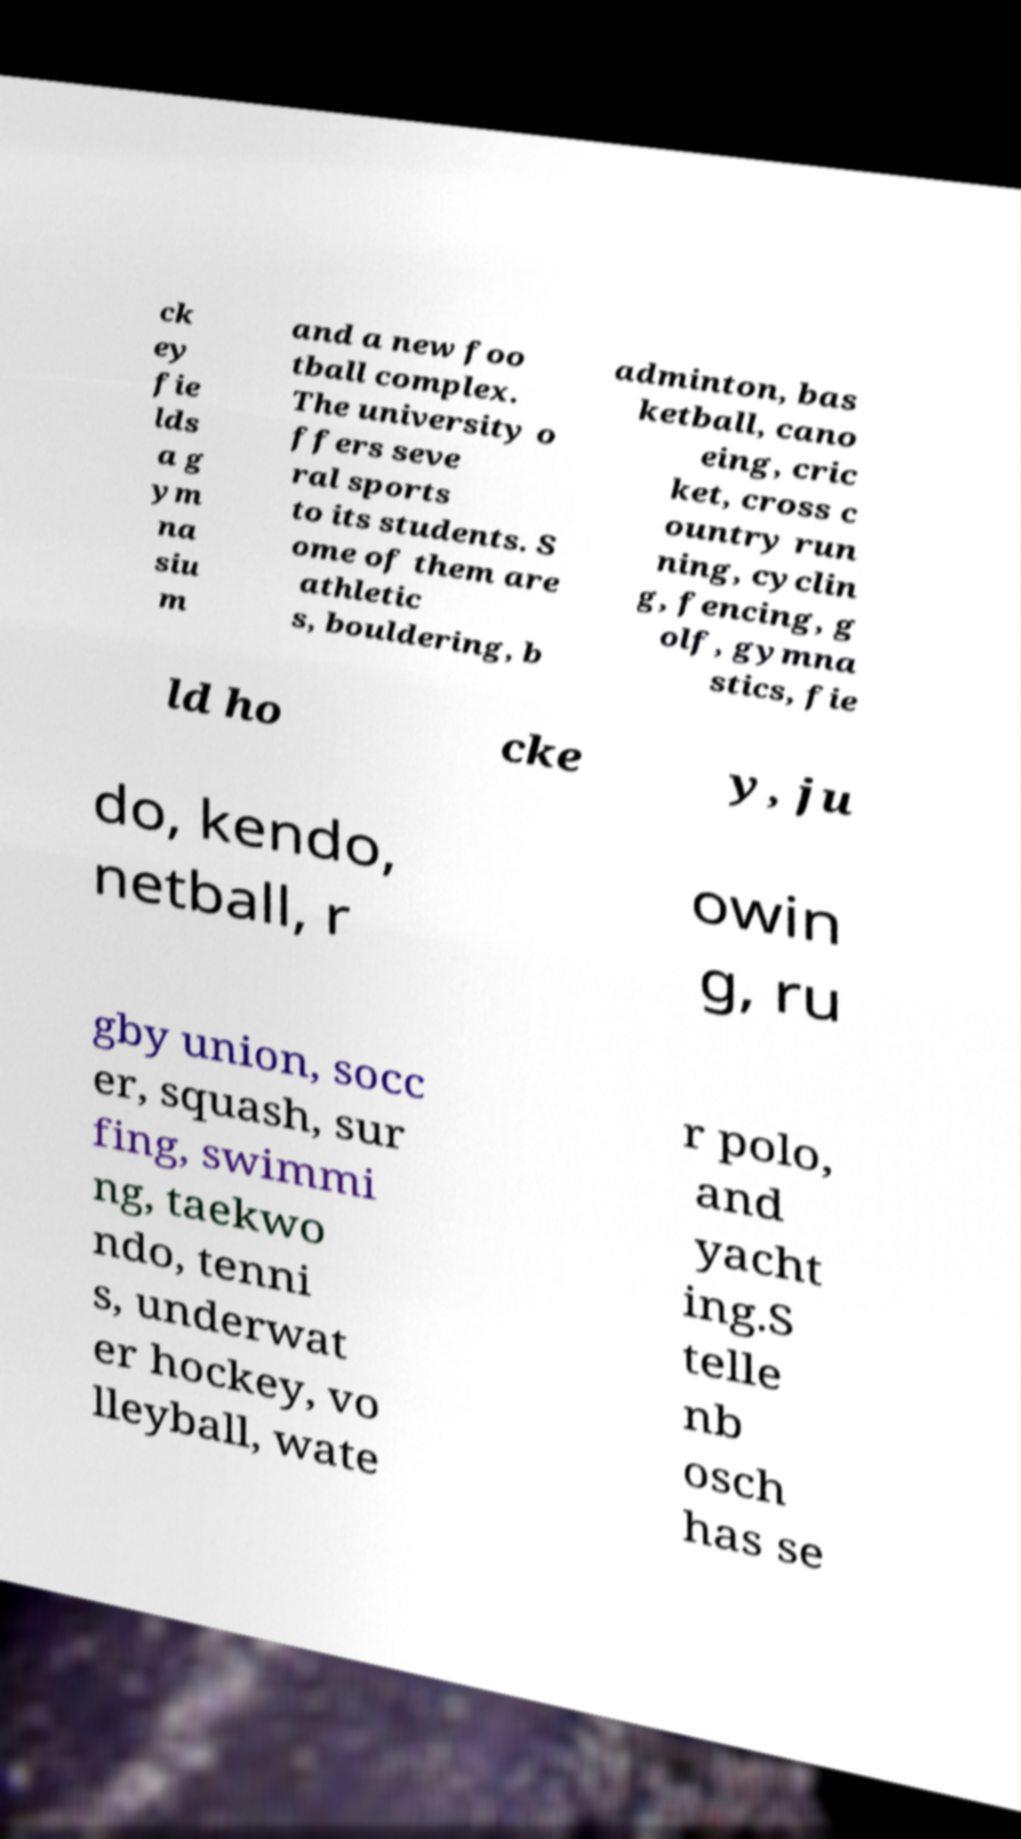There's text embedded in this image that I need extracted. Can you transcribe it verbatim? ck ey fie lds a g ym na siu m and a new foo tball complex. The university o ffers seve ral sports to its students. S ome of them are athletic s, bouldering, b adminton, bas ketball, cano eing, cric ket, cross c ountry run ning, cyclin g, fencing, g olf, gymna stics, fie ld ho cke y, ju do, kendo, netball, r owin g, ru gby union, socc er, squash, sur fing, swimmi ng, taekwo ndo, tenni s, underwat er hockey, vo lleyball, wate r polo, and yacht ing.S telle nb osch has se 